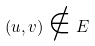Convert formula to latex. <formula><loc_0><loc_0><loc_500><loc_500>( u , v ) \notin E</formula> 